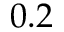<formula> <loc_0><loc_0><loc_500><loc_500>0 . 2</formula> 